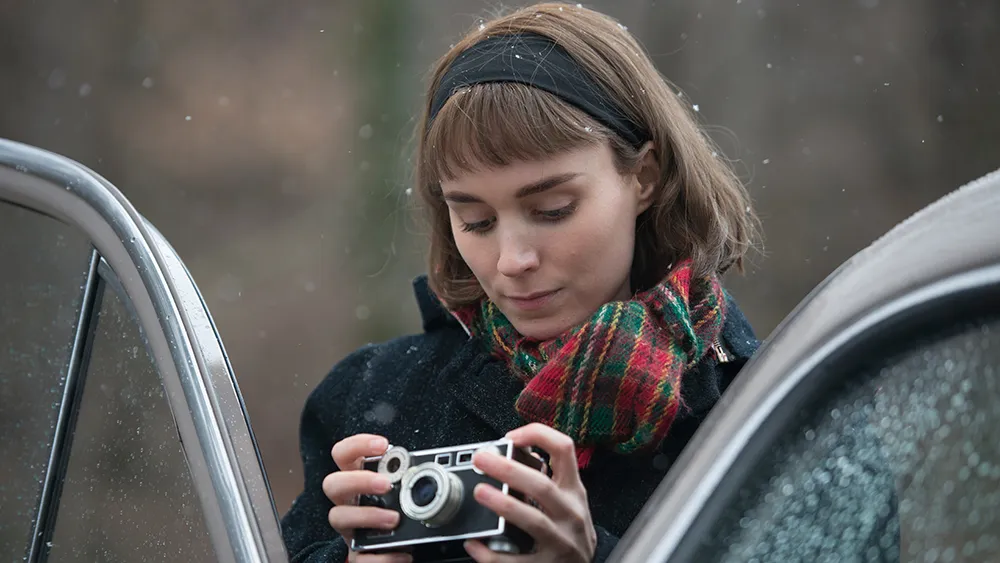Describe the colors and lighting in the image. The image features a subtle and muted palette, dominated by natural and subdued tones. The woman's black coat provides a stark contrast against the softer shades of the blurred background. The red and green plaid scarf she wears stands out vibrantly, adding a touch of warmth and festive spirit. The lighting is soft and diffused, likely due to the overcast weather conditions, lending a serene and contemplative atmosphere to the scene. The light bounces gently off the raindrops speckled on the car, adding to the overall calm and peaceful ambiance.  Imagine the soundscape of this scene. What sounds would you expect to hear? In this tranquil scene, one might expect to hear the gentle patter of rain droplets on the car and the soft rustling of leaves in the wind. The forested background could be filled with the distant chirping of birds, creating a calming natural soundscape. Occasionally, the click of the camera's shutter adds to the ambiance, accompanied by the faint sound of the woman's movements as she adjusts her grip on the camera. This harmonious blend of natural and human-made sounds enhances the peaceful and introspective mood of the moment.  If this scene was part of a movie, what kind of story could it be telling? This scene could be part of a poignant drama or romance film, telling the story of a character who is capturing memories through her camera. The woman might be a photographer or an artist, taking a quiet moment to herself in a picturesque location. This peaceful interlude could be a reflection of her inner world, filled with contemplation and nostalgia. Alternatively, she could be waiting for someone, with the raindrops and the serene setting symbolizing a moment of anticipation and longing. The combination of her focused expression and the tranquil environment hints at a deeper narrative filled with emotion and introspection.  What if the car in the image had a magical power? What could it be? If the car in the image had a magical power, it could be a time machine, capable of transporting its passengers to any moment in history. The woman, with her vintage camera, might be on a journey to capture historical events or relive cherished memories from her past. The raindrops on the car might act as a portal, with each droplet representing a different moment in time. As she stands there, she could be pondering the next destination, ready to embark on a new adventure filled with wonder and discovery. The serene woodland setting might serve as a safe haven where she calibrates her car's magical abilities before setting off on another exhilarating journey through time.  If this image represents a pivotal moment in a novel, what themes or emotions could it be exploring? This image could represent a pivotal moment in a novel exploring themes of introspection, nostalgia, and the passage of time. The woman's focused attention on the camera suggests a deep connection to capturing and preserving memories, hinting at a past filled with significant moments. The quiet, rain-speckled setting evokes a sense of calm and reflection, as if she is taking a moment to pause and consider her journey. Themes of solitude, contemplation, and the beauty of simple, serene moments could be explored, with the image symbolizing a turning point where the character gains clarity or makes an important decision. 